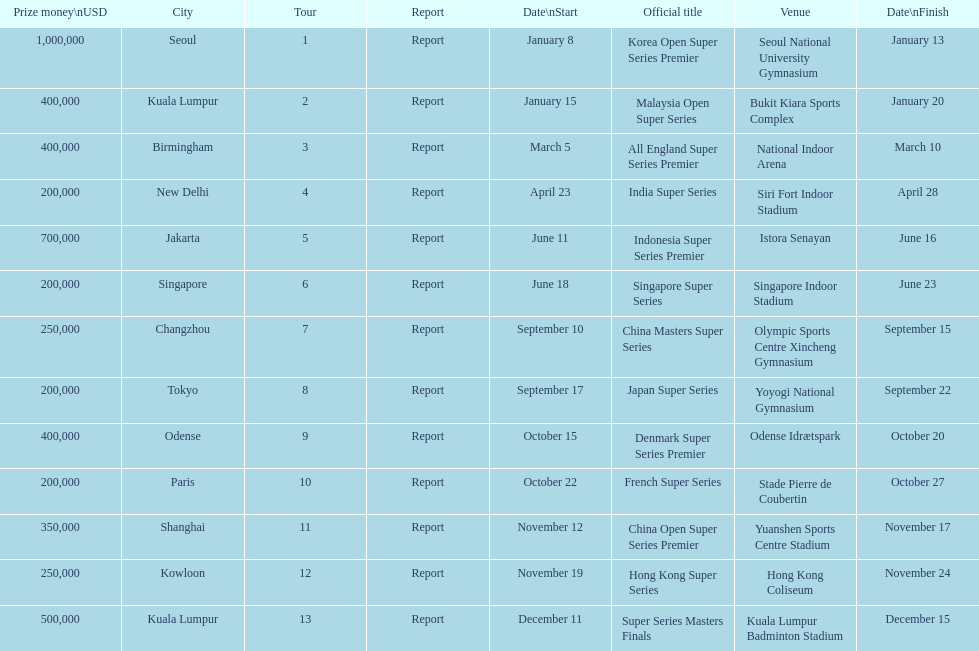Does the malaysia open super series pay more or less than french super series? More. 